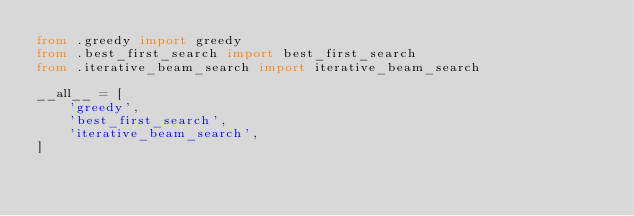<code> <loc_0><loc_0><loc_500><loc_500><_Python_>from .greedy import greedy
from .best_first_search import best_first_search
from .iterative_beam_search import iterative_beam_search

__all__ = [
    'greedy',
    'best_first_search',
    'iterative_beam_search',
]
</code> 